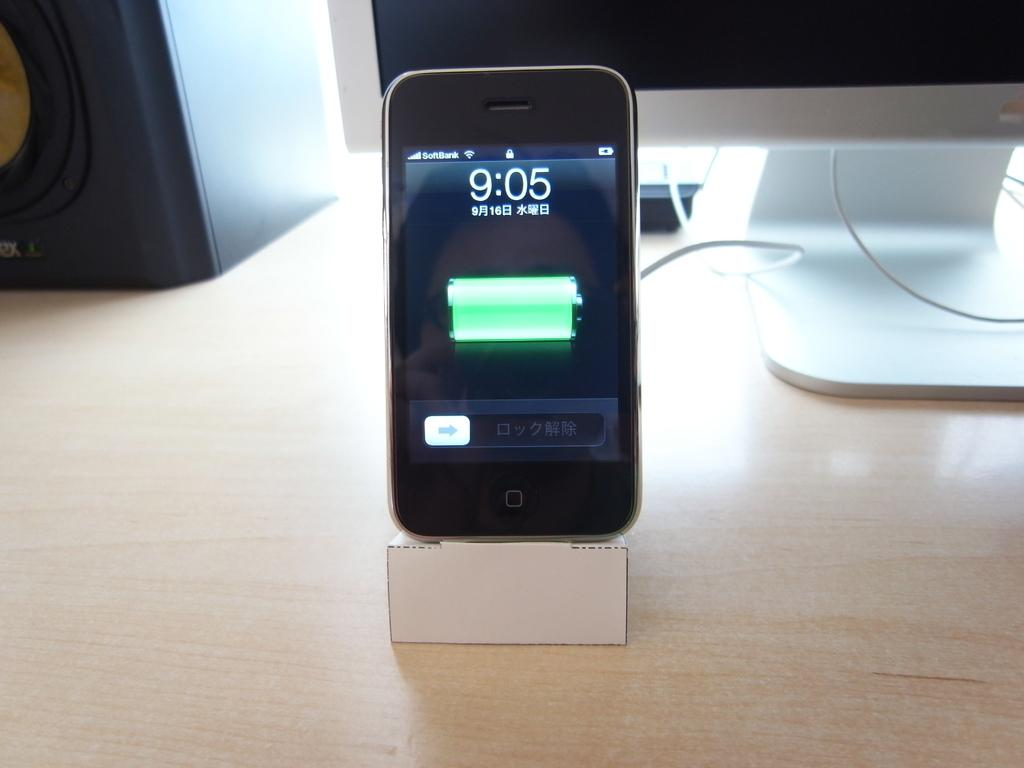Provide a one-sentence caption for the provided image. a phone that has the time of 9:05 on it. 